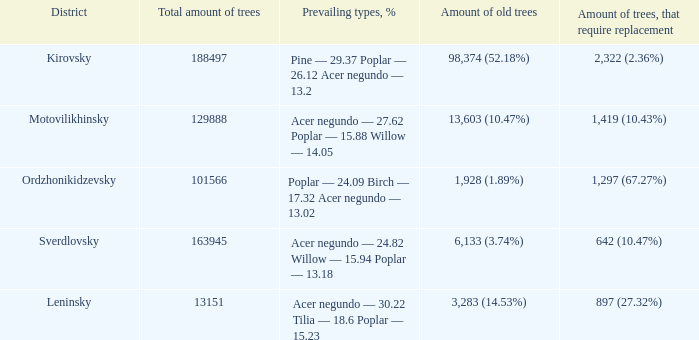What is the amount of trees, that require replacement when district is leninsky? 897 (27.32%). 